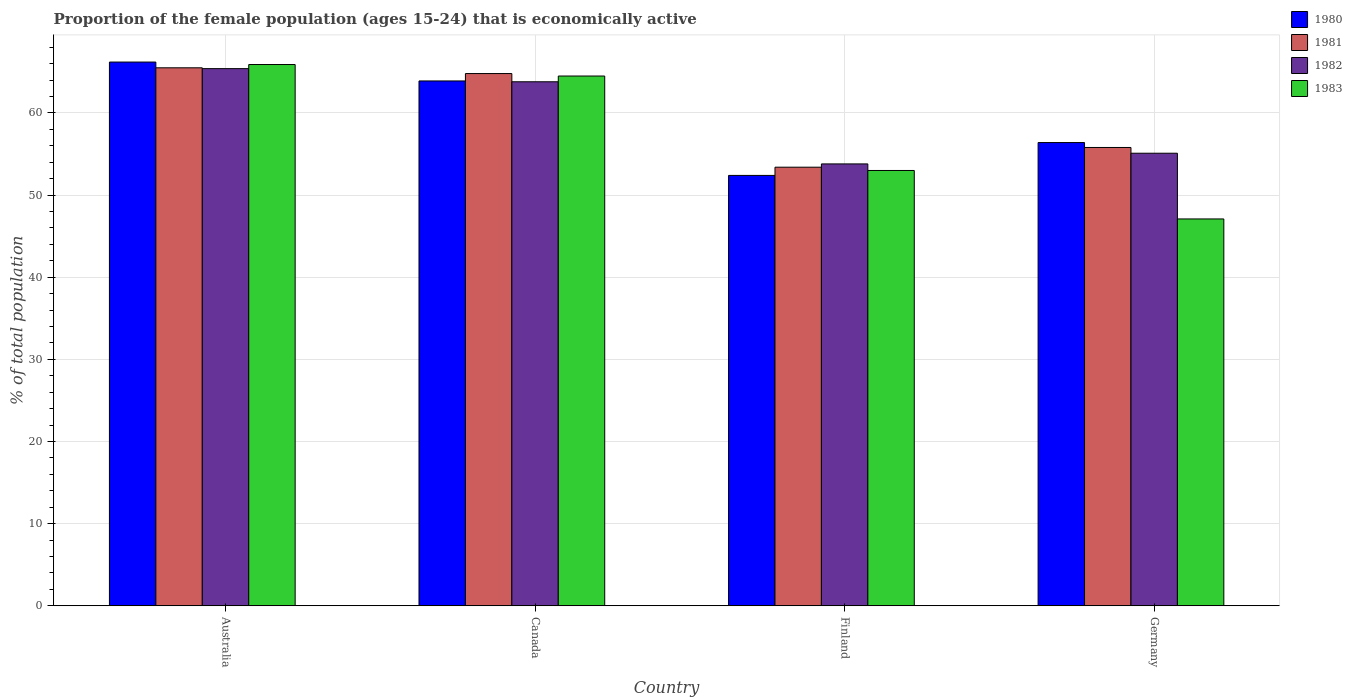Are the number of bars per tick equal to the number of legend labels?
Your answer should be very brief. Yes. Are the number of bars on each tick of the X-axis equal?
Provide a succinct answer. Yes. How many bars are there on the 4th tick from the left?
Make the answer very short. 4. How many bars are there on the 3rd tick from the right?
Give a very brief answer. 4. What is the proportion of the female population that is economically active in 1980 in Canada?
Offer a terse response. 63.9. Across all countries, what is the maximum proportion of the female population that is economically active in 1982?
Keep it short and to the point. 65.4. Across all countries, what is the minimum proportion of the female population that is economically active in 1981?
Give a very brief answer. 53.4. What is the total proportion of the female population that is economically active in 1981 in the graph?
Make the answer very short. 239.5. What is the difference between the proportion of the female population that is economically active in 1980 in Australia and that in Germany?
Your answer should be very brief. 9.8. What is the difference between the proportion of the female population that is economically active in 1983 in Australia and the proportion of the female population that is economically active in 1980 in Finland?
Make the answer very short. 13.5. What is the average proportion of the female population that is economically active in 1982 per country?
Provide a succinct answer. 59.52. What is the difference between the proportion of the female population that is economically active of/in 1980 and proportion of the female population that is economically active of/in 1981 in Germany?
Provide a succinct answer. 0.6. In how many countries, is the proportion of the female population that is economically active in 1982 greater than 58 %?
Your answer should be compact. 2. What is the ratio of the proportion of the female population that is economically active in 1980 in Australia to that in Germany?
Make the answer very short. 1.17. Is the difference between the proportion of the female population that is economically active in 1980 in Australia and Germany greater than the difference between the proportion of the female population that is economically active in 1981 in Australia and Germany?
Your answer should be very brief. Yes. What is the difference between the highest and the second highest proportion of the female population that is economically active in 1981?
Provide a succinct answer. -0.7. What is the difference between the highest and the lowest proportion of the female population that is economically active in 1983?
Offer a terse response. 18.8. How many countries are there in the graph?
Ensure brevity in your answer.  4. Where does the legend appear in the graph?
Ensure brevity in your answer.  Top right. What is the title of the graph?
Offer a very short reply. Proportion of the female population (ages 15-24) that is economically active. Does "1983" appear as one of the legend labels in the graph?
Provide a succinct answer. Yes. What is the label or title of the Y-axis?
Your answer should be compact. % of total population. What is the % of total population of 1980 in Australia?
Provide a succinct answer. 66.2. What is the % of total population in 1981 in Australia?
Your answer should be very brief. 65.5. What is the % of total population in 1982 in Australia?
Offer a terse response. 65.4. What is the % of total population of 1983 in Australia?
Keep it short and to the point. 65.9. What is the % of total population in 1980 in Canada?
Provide a succinct answer. 63.9. What is the % of total population of 1981 in Canada?
Keep it short and to the point. 64.8. What is the % of total population of 1982 in Canada?
Ensure brevity in your answer.  63.8. What is the % of total population of 1983 in Canada?
Provide a short and direct response. 64.5. What is the % of total population of 1980 in Finland?
Offer a very short reply. 52.4. What is the % of total population of 1981 in Finland?
Provide a short and direct response. 53.4. What is the % of total population in 1982 in Finland?
Provide a short and direct response. 53.8. What is the % of total population of 1983 in Finland?
Provide a succinct answer. 53. What is the % of total population of 1980 in Germany?
Provide a short and direct response. 56.4. What is the % of total population in 1981 in Germany?
Provide a short and direct response. 55.8. What is the % of total population of 1982 in Germany?
Ensure brevity in your answer.  55.1. What is the % of total population in 1983 in Germany?
Ensure brevity in your answer.  47.1. Across all countries, what is the maximum % of total population in 1980?
Provide a short and direct response. 66.2. Across all countries, what is the maximum % of total population in 1981?
Provide a short and direct response. 65.5. Across all countries, what is the maximum % of total population of 1982?
Offer a very short reply. 65.4. Across all countries, what is the maximum % of total population of 1983?
Provide a succinct answer. 65.9. Across all countries, what is the minimum % of total population of 1980?
Give a very brief answer. 52.4. Across all countries, what is the minimum % of total population in 1981?
Give a very brief answer. 53.4. Across all countries, what is the minimum % of total population of 1982?
Your response must be concise. 53.8. Across all countries, what is the minimum % of total population of 1983?
Your answer should be compact. 47.1. What is the total % of total population of 1980 in the graph?
Your response must be concise. 238.9. What is the total % of total population of 1981 in the graph?
Make the answer very short. 239.5. What is the total % of total population of 1982 in the graph?
Provide a succinct answer. 238.1. What is the total % of total population in 1983 in the graph?
Make the answer very short. 230.5. What is the difference between the % of total population in 1982 in Australia and that in Canada?
Provide a short and direct response. 1.6. What is the difference between the % of total population of 1983 in Australia and that in Canada?
Give a very brief answer. 1.4. What is the difference between the % of total population of 1980 in Australia and that in Finland?
Offer a very short reply. 13.8. What is the difference between the % of total population of 1981 in Australia and that in Finland?
Your response must be concise. 12.1. What is the difference between the % of total population of 1982 in Australia and that in Finland?
Your answer should be very brief. 11.6. What is the difference between the % of total population in 1981 in Australia and that in Germany?
Ensure brevity in your answer.  9.7. What is the difference between the % of total population in 1982 in Australia and that in Germany?
Your answer should be very brief. 10.3. What is the difference between the % of total population in 1983 in Australia and that in Germany?
Your answer should be very brief. 18.8. What is the difference between the % of total population in 1983 in Canada and that in Germany?
Offer a very short reply. 17.4. What is the difference between the % of total population of 1981 in Finland and that in Germany?
Offer a very short reply. -2.4. What is the difference between the % of total population in 1983 in Finland and that in Germany?
Give a very brief answer. 5.9. What is the difference between the % of total population in 1980 in Australia and the % of total population in 1983 in Canada?
Provide a short and direct response. 1.7. What is the difference between the % of total population in 1981 in Australia and the % of total population in 1982 in Canada?
Give a very brief answer. 1.7. What is the difference between the % of total population of 1981 in Australia and the % of total population of 1983 in Canada?
Provide a short and direct response. 1. What is the difference between the % of total population of 1982 in Australia and the % of total population of 1983 in Canada?
Give a very brief answer. 0.9. What is the difference between the % of total population in 1980 in Australia and the % of total population in 1981 in Finland?
Give a very brief answer. 12.8. What is the difference between the % of total population in 1981 in Australia and the % of total population in 1982 in Finland?
Your response must be concise. 11.7. What is the difference between the % of total population of 1982 in Australia and the % of total population of 1983 in Finland?
Provide a succinct answer. 12.4. What is the difference between the % of total population of 1980 in Australia and the % of total population of 1981 in Germany?
Make the answer very short. 10.4. What is the difference between the % of total population in 1980 in Australia and the % of total population in 1983 in Germany?
Your response must be concise. 19.1. What is the difference between the % of total population of 1981 in Australia and the % of total population of 1983 in Germany?
Your answer should be very brief. 18.4. What is the difference between the % of total population in 1982 in Australia and the % of total population in 1983 in Germany?
Ensure brevity in your answer.  18.3. What is the difference between the % of total population of 1980 in Canada and the % of total population of 1981 in Finland?
Offer a very short reply. 10.5. What is the difference between the % of total population of 1980 in Canada and the % of total population of 1982 in Finland?
Your response must be concise. 10.1. What is the difference between the % of total population of 1980 in Canada and the % of total population of 1983 in Finland?
Make the answer very short. 10.9. What is the difference between the % of total population of 1982 in Canada and the % of total population of 1983 in Finland?
Your response must be concise. 10.8. What is the difference between the % of total population in 1980 in Canada and the % of total population in 1981 in Germany?
Offer a very short reply. 8.1. What is the difference between the % of total population in 1982 in Canada and the % of total population in 1983 in Germany?
Keep it short and to the point. 16.7. What is the difference between the % of total population of 1980 in Finland and the % of total population of 1982 in Germany?
Offer a very short reply. -2.7. What is the difference between the % of total population in 1980 in Finland and the % of total population in 1983 in Germany?
Provide a succinct answer. 5.3. What is the difference between the % of total population of 1982 in Finland and the % of total population of 1983 in Germany?
Provide a short and direct response. 6.7. What is the average % of total population of 1980 per country?
Your response must be concise. 59.73. What is the average % of total population of 1981 per country?
Offer a terse response. 59.88. What is the average % of total population in 1982 per country?
Keep it short and to the point. 59.52. What is the average % of total population in 1983 per country?
Provide a short and direct response. 57.62. What is the difference between the % of total population in 1980 and % of total population in 1981 in Australia?
Your answer should be very brief. 0.7. What is the difference between the % of total population in 1982 and % of total population in 1983 in Australia?
Your response must be concise. -0.5. What is the difference between the % of total population of 1980 and % of total population of 1983 in Canada?
Offer a terse response. -0.6. What is the difference between the % of total population of 1981 and % of total population of 1983 in Canada?
Make the answer very short. 0.3. What is the difference between the % of total population of 1980 and % of total population of 1982 in Finland?
Your answer should be compact. -1.4. What is the difference between the % of total population of 1981 and % of total population of 1982 in Finland?
Offer a very short reply. -0.4. What is the difference between the % of total population in 1980 and % of total population in 1981 in Germany?
Make the answer very short. 0.6. What is the difference between the % of total population in 1981 and % of total population in 1983 in Germany?
Offer a very short reply. 8.7. What is the difference between the % of total population of 1982 and % of total population of 1983 in Germany?
Make the answer very short. 8. What is the ratio of the % of total population in 1980 in Australia to that in Canada?
Give a very brief answer. 1.04. What is the ratio of the % of total population in 1981 in Australia to that in Canada?
Provide a succinct answer. 1.01. What is the ratio of the % of total population in 1982 in Australia to that in Canada?
Provide a short and direct response. 1.03. What is the ratio of the % of total population of 1983 in Australia to that in Canada?
Make the answer very short. 1.02. What is the ratio of the % of total population of 1980 in Australia to that in Finland?
Provide a short and direct response. 1.26. What is the ratio of the % of total population of 1981 in Australia to that in Finland?
Make the answer very short. 1.23. What is the ratio of the % of total population in 1982 in Australia to that in Finland?
Your answer should be very brief. 1.22. What is the ratio of the % of total population in 1983 in Australia to that in Finland?
Provide a short and direct response. 1.24. What is the ratio of the % of total population in 1980 in Australia to that in Germany?
Make the answer very short. 1.17. What is the ratio of the % of total population of 1981 in Australia to that in Germany?
Ensure brevity in your answer.  1.17. What is the ratio of the % of total population of 1982 in Australia to that in Germany?
Your answer should be compact. 1.19. What is the ratio of the % of total population of 1983 in Australia to that in Germany?
Provide a succinct answer. 1.4. What is the ratio of the % of total population of 1980 in Canada to that in Finland?
Provide a short and direct response. 1.22. What is the ratio of the % of total population of 1981 in Canada to that in Finland?
Make the answer very short. 1.21. What is the ratio of the % of total population in 1982 in Canada to that in Finland?
Make the answer very short. 1.19. What is the ratio of the % of total population in 1983 in Canada to that in Finland?
Ensure brevity in your answer.  1.22. What is the ratio of the % of total population in 1980 in Canada to that in Germany?
Your answer should be compact. 1.13. What is the ratio of the % of total population in 1981 in Canada to that in Germany?
Provide a short and direct response. 1.16. What is the ratio of the % of total population of 1982 in Canada to that in Germany?
Your answer should be compact. 1.16. What is the ratio of the % of total population of 1983 in Canada to that in Germany?
Your answer should be very brief. 1.37. What is the ratio of the % of total population of 1980 in Finland to that in Germany?
Provide a short and direct response. 0.93. What is the ratio of the % of total population in 1982 in Finland to that in Germany?
Ensure brevity in your answer.  0.98. What is the ratio of the % of total population of 1983 in Finland to that in Germany?
Offer a terse response. 1.13. What is the difference between the highest and the second highest % of total population in 1980?
Offer a terse response. 2.3. What is the difference between the highest and the second highest % of total population in 1981?
Provide a short and direct response. 0.7. What is the difference between the highest and the second highest % of total population in 1983?
Ensure brevity in your answer.  1.4. What is the difference between the highest and the lowest % of total population in 1980?
Your answer should be very brief. 13.8. What is the difference between the highest and the lowest % of total population in 1981?
Your answer should be very brief. 12.1. What is the difference between the highest and the lowest % of total population in 1982?
Provide a short and direct response. 11.6. What is the difference between the highest and the lowest % of total population in 1983?
Make the answer very short. 18.8. 